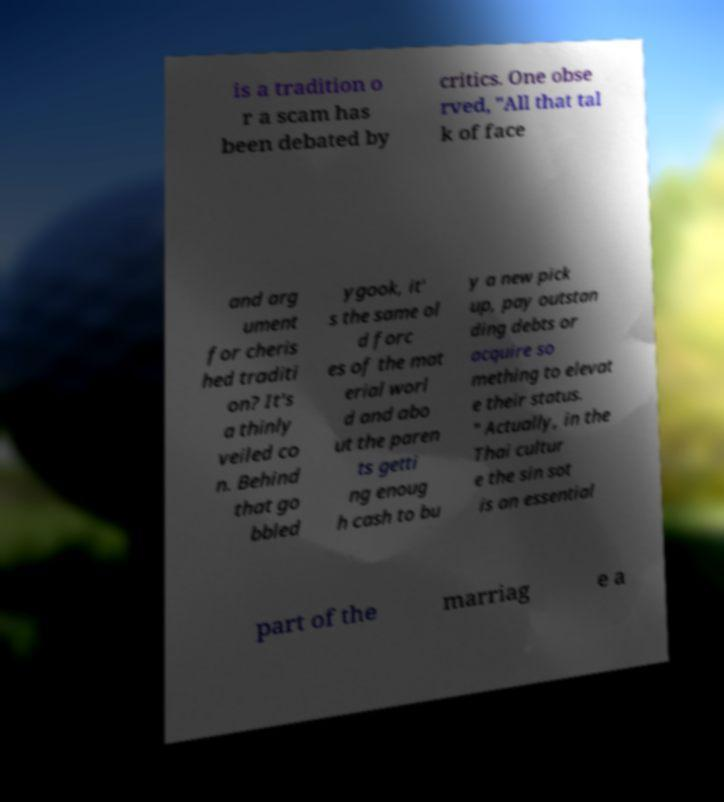Can you read and provide the text displayed in the image?This photo seems to have some interesting text. Can you extract and type it out for me? is a tradition o r a scam has been debated by critics. One obse rved, "All that tal k of face and arg ument for cheris hed traditi on? It's a thinly veiled co n. Behind that go bbled ygook, it' s the same ol d forc es of the mat erial worl d and abo ut the paren ts getti ng enoug h cash to bu y a new pick up, pay outstan ding debts or acquire so mething to elevat e their status. " Actually, in the Thai cultur e the sin sot is an essential part of the marriag e a 